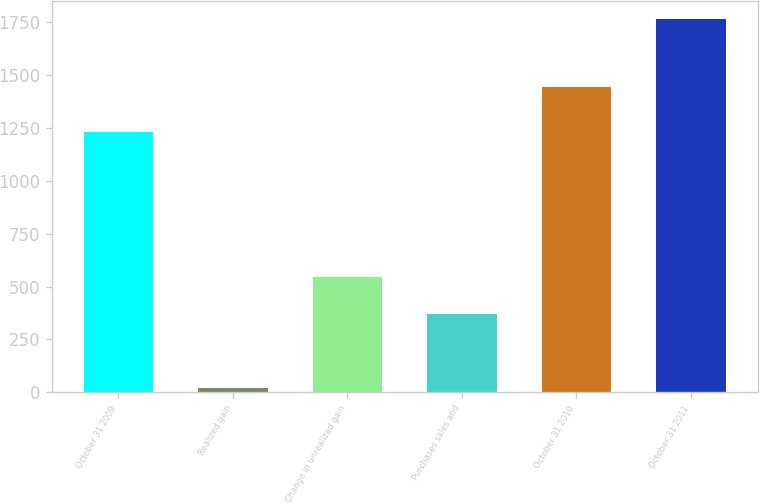Convert chart to OTSL. <chart><loc_0><loc_0><loc_500><loc_500><bar_chart><fcel>October 31 2009<fcel>Realized gain<fcel>Change in unrealized gain<fcel>Purchases sales and<fcel>October 31 2010<fcel>October 31 2011<nl><fcel>1233<fcel>21<fcel>544.2<fcel>369.8<fcel>1443<fcel>1765<nl></chart> 